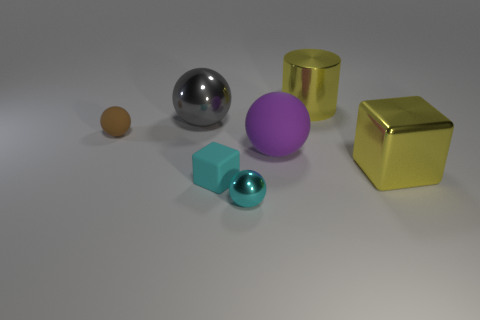There is a shiny thing right of the big metallic cylinder; are there any purple rubber objects behind it?
Give a very brief answer. Yes. Is the number of small brown matte things less than the number of gray rubber spheres?
Offer a very short reply. No. How many tiny cyan matte objects are the same shape as the large rubber thing?
Give a very brief answer. 0. How many cyan things are either metallic spheres or tiny rubber objects?
Your answer should be compact. 2. How big is the matte object that is in front of the rubber sphere in front of the small brown rubber object?
Make the answer very short. Small. What material is the large gray thing that is the same shape as the purple thing?
Your answer should be compact. Metal. What number of brown spheres have the same size as the shiny block?
Keep it short and to the point. 0. Is the size of the purple matte ball the same as the matte cube?
Your answer should be compact. No. How big is the metal thing that is in front of the large rubber thing and behind the cyan block?
Your response must be concise. Large. Is the number of small balls that are behind the tiny cyan ball greater than the number of cyan rubber blocks behind the big metallic cylinder?
Your answer should be compact. Yes. 